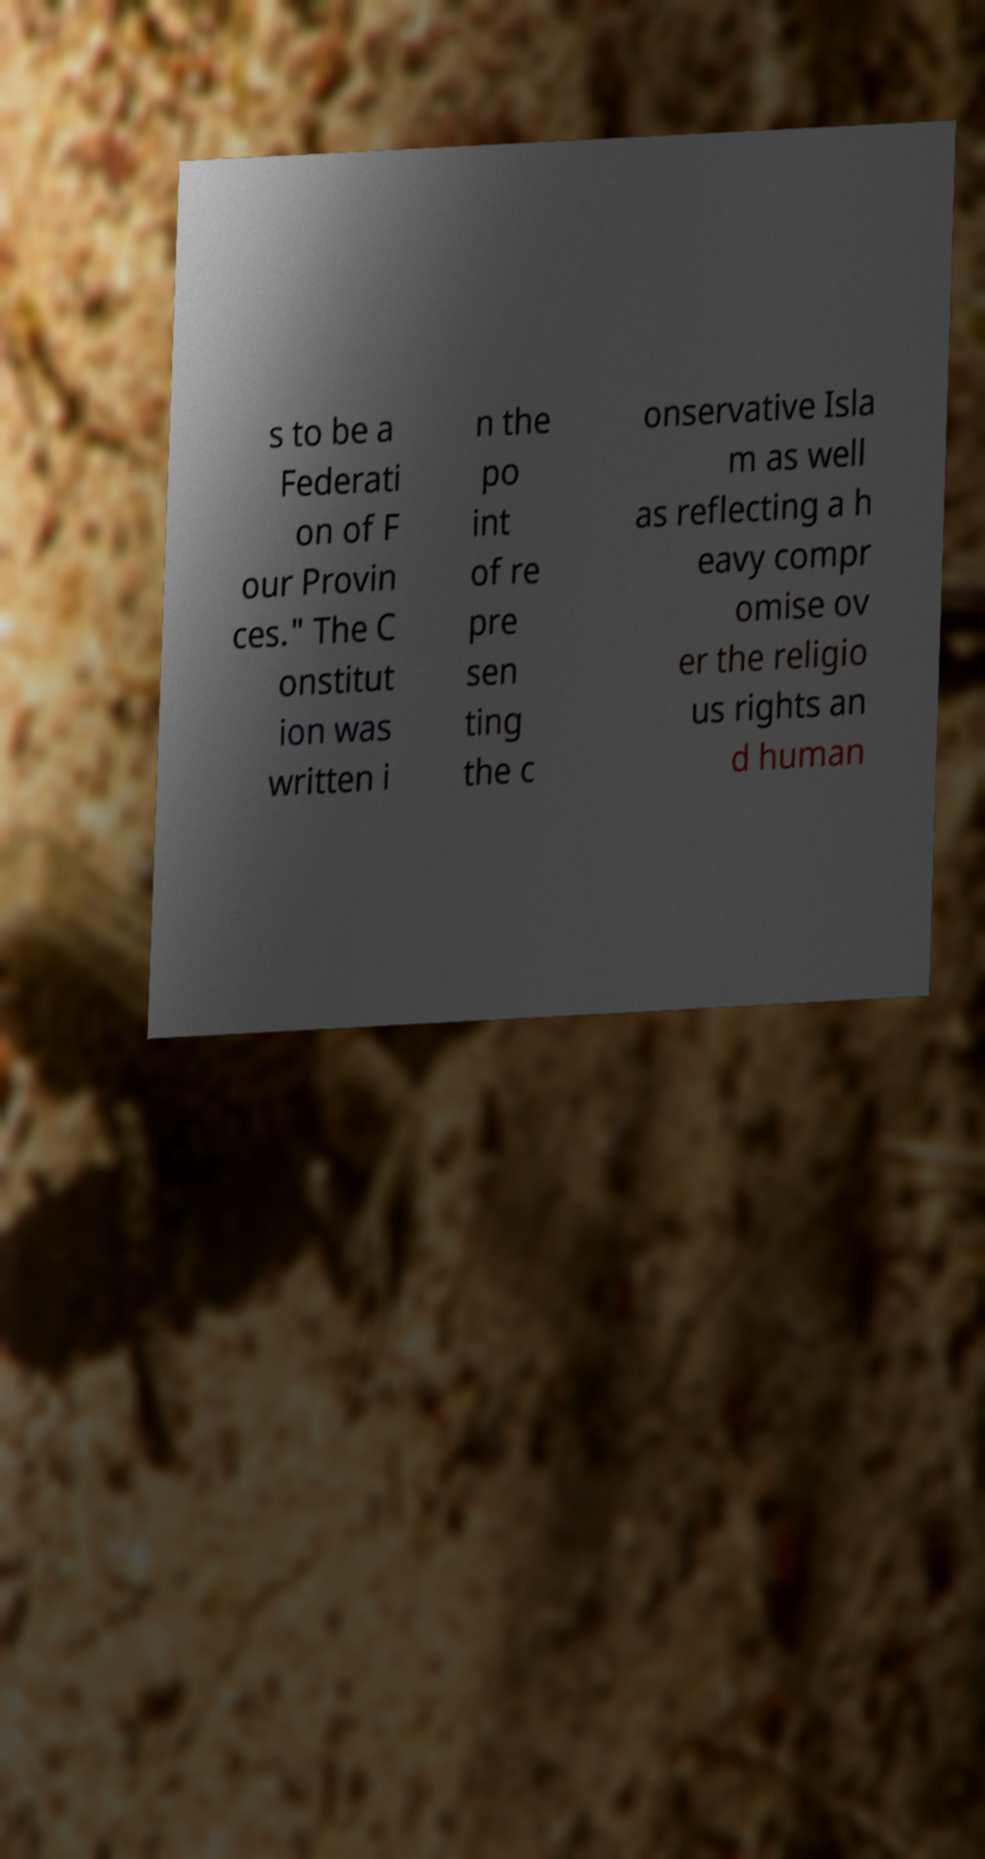Could you assist in decoding the text presented in this image and type it out clearly? s to be a Federati on of F our Provin ces." The C onstitut ion was written i n the po int of re pre sen ting the c onservative Isla m as well as reflecting a h eavy compr omise ov er the religio us rights an d human 